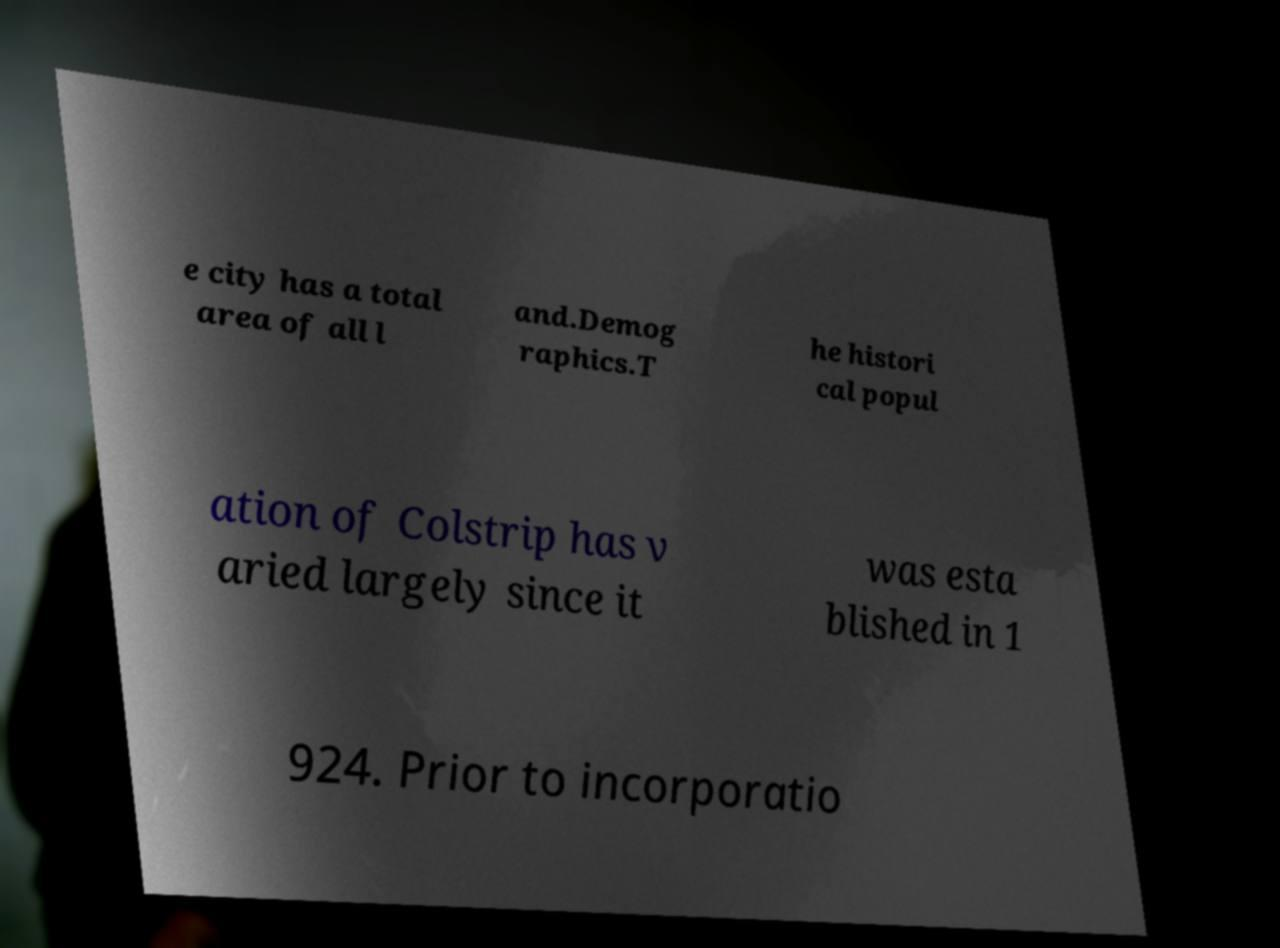Can you accurately transcribe the text from the provided image for me? e city has a total area of all l and.Demog raphics.T he histori cal popul ation of Colstrip has v aried largely since it was esta blished in 1 924. Prior to incorporatio 